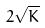<formula> <loc_0><loc_0><loc_500><loc_500>2 \sqrt { K }</formula> 